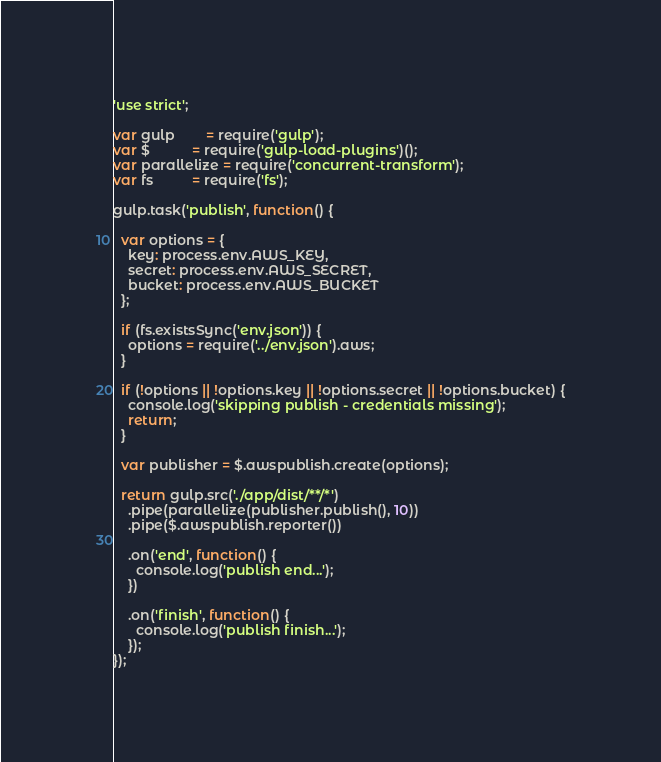<code> <loc_0><loc_0><loc_500><loc_500><_JavaScript_>'use strict';

var gulp        = require('gulp');
var $           = require('gulp-load-plugins')();
var parallelize = require('concurrent-transform');
var fs          = require('fs');

gulp.task('publish', function() {

  var options = {
    key: process.env.AWS_KEY,
    secret: process.env.AWS_SECRET,
    bucket: process.env.AWS_BUCKET
  };

  if (fs.existsSync('env.json')) {
    options = require('../env.json').aws;
  }

  if (!options || !options.key || !options.secret || !options.bucket) {
    console.log('skipping publish - credentials missing');
    return;
  }

  var publisher = $.awspublish.create(options);

  return gulp.src('./app/dist/**/*')
    .pipe(parallelize(publisher.publish(), 10))
    .pipe($.awspublish.reporter())

    .on('end', function() {
      console.log('publish end...');
    })

    .on('finish', function() {
      console.log('publish finish...');
    });
});
</code> 